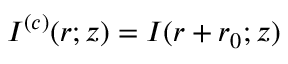<formula> <loc_0><loc_0><loc_500><loc_500>\begin{array} { r } { I ^ { ( c ) } ( r ; z ) = I ( r + r _ { 0 } ; z ) } \end{array}</formula> 